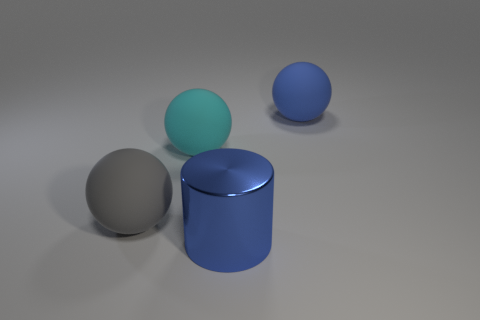Is the number of large shiny things that are in front of the large blue ball greater than the number of big gray things left of the gray rubber thing? Upon examining the image carefully, it appears that there is one large shiny silver ball in front of the large blue ball. To the left of the cylindrical gray object, there are no other large objects present. Therefore, the number of large shiny things in front of the blue ball, which is one, is not greater than the number of big gray things left of the gray rubber thing, since there are none. 